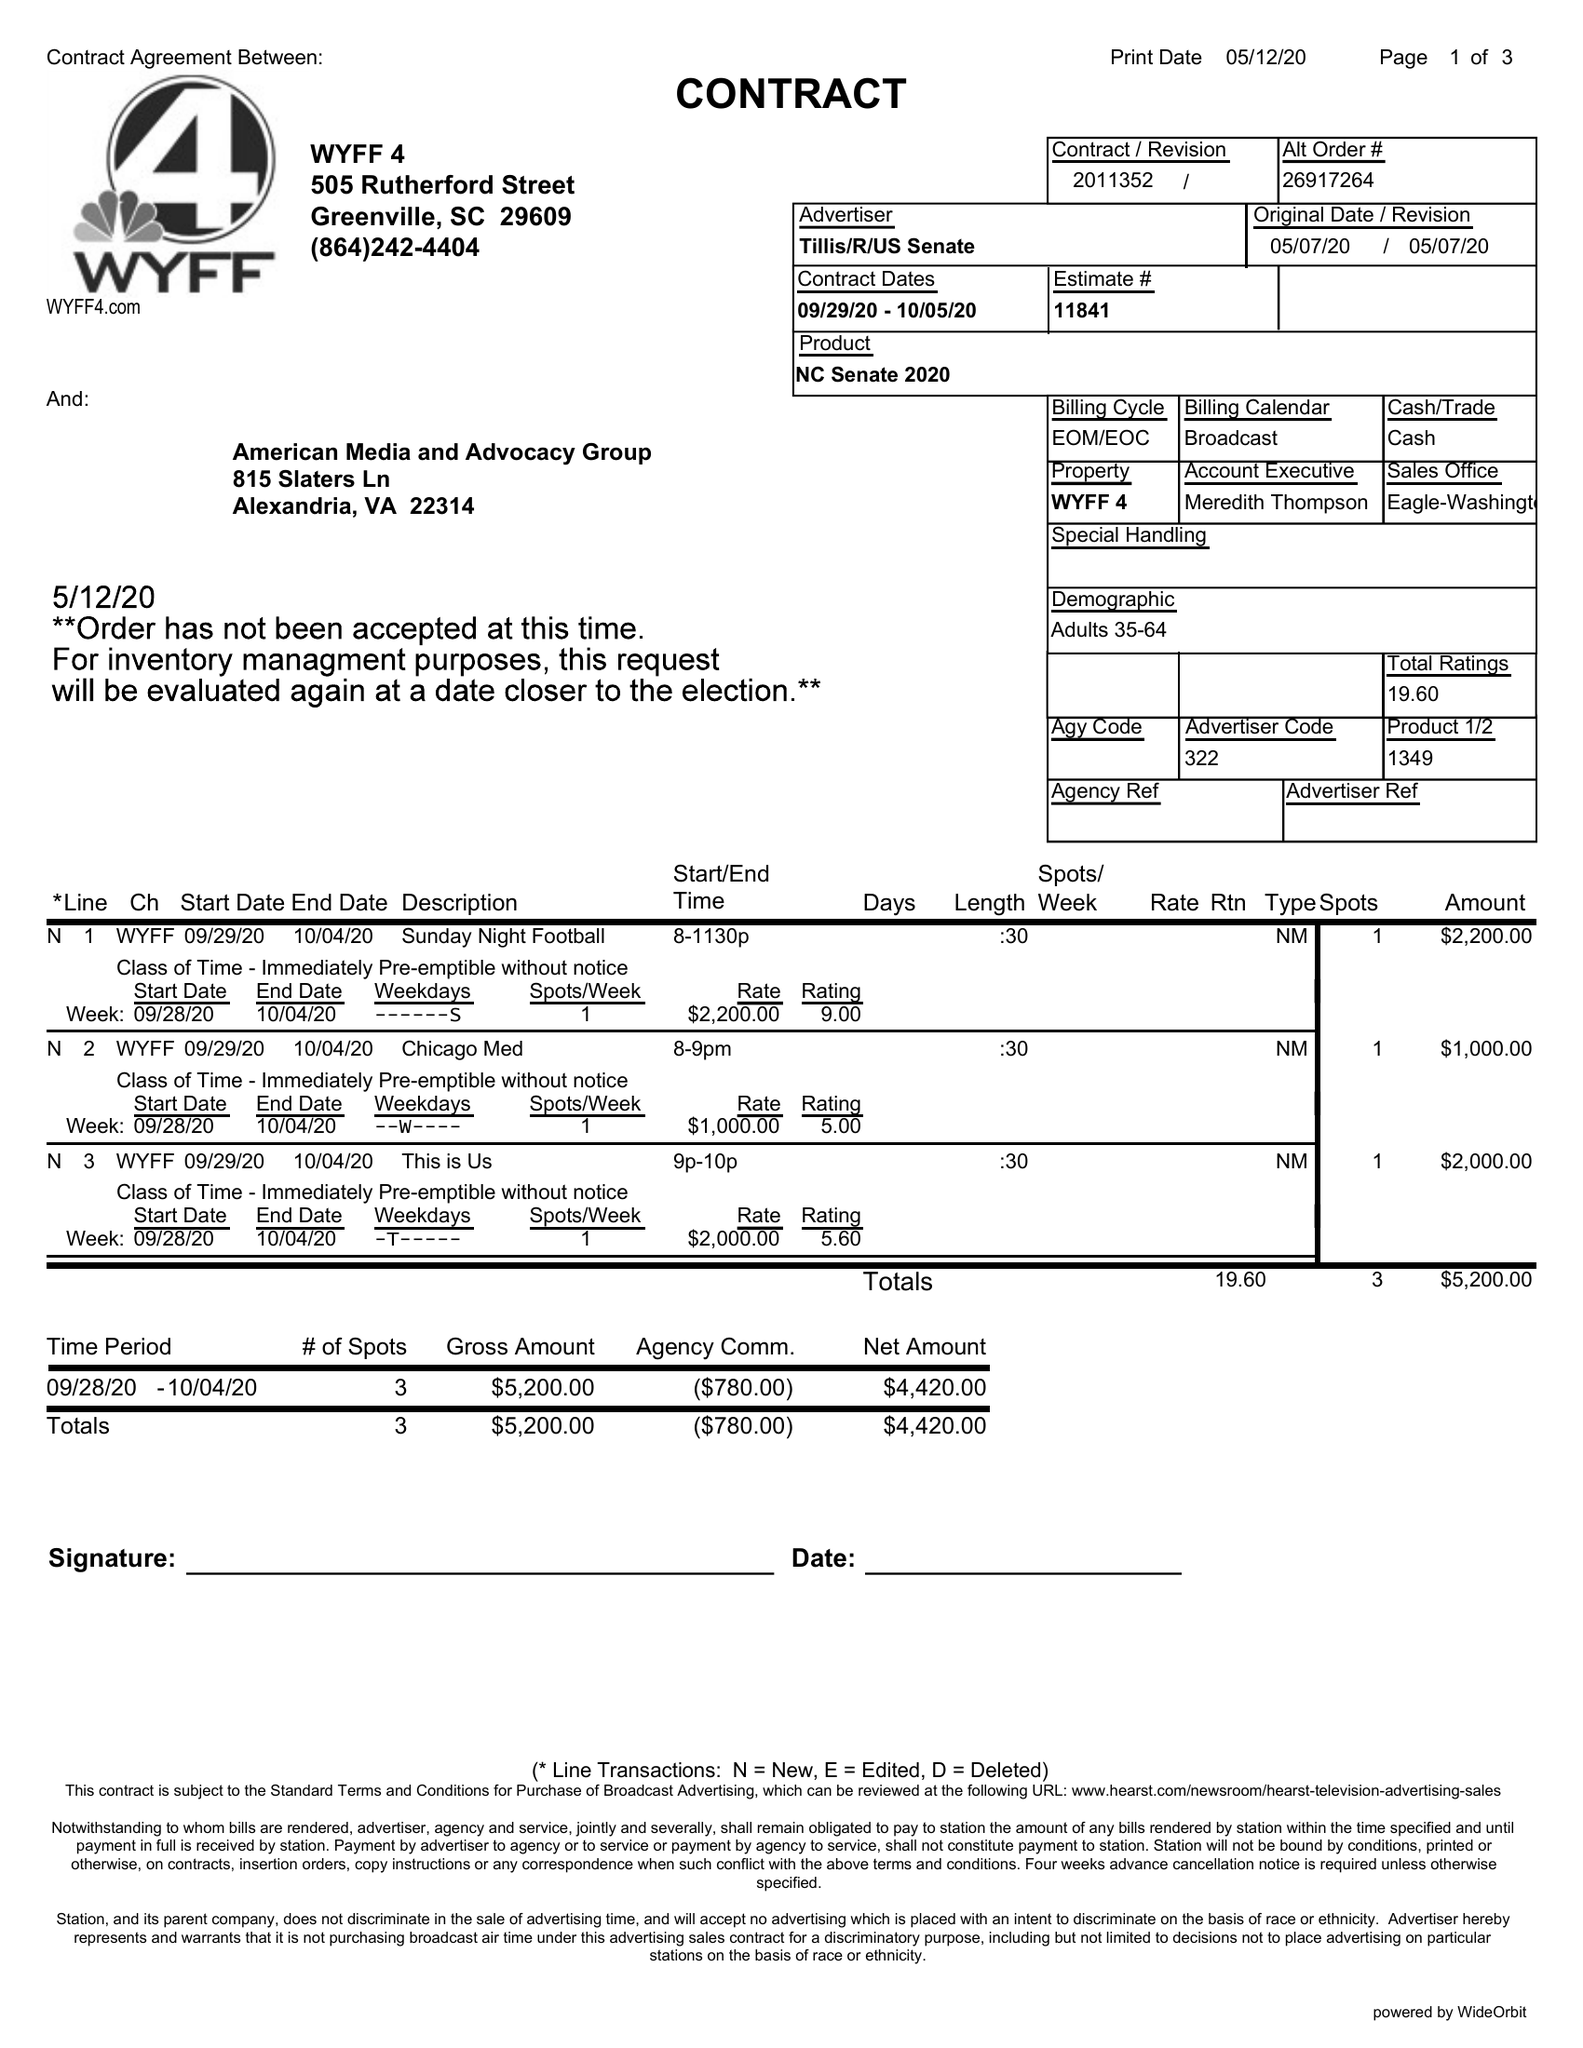What is the value for the contract_num?
Answer the question using a single word or phrase. 2011352 